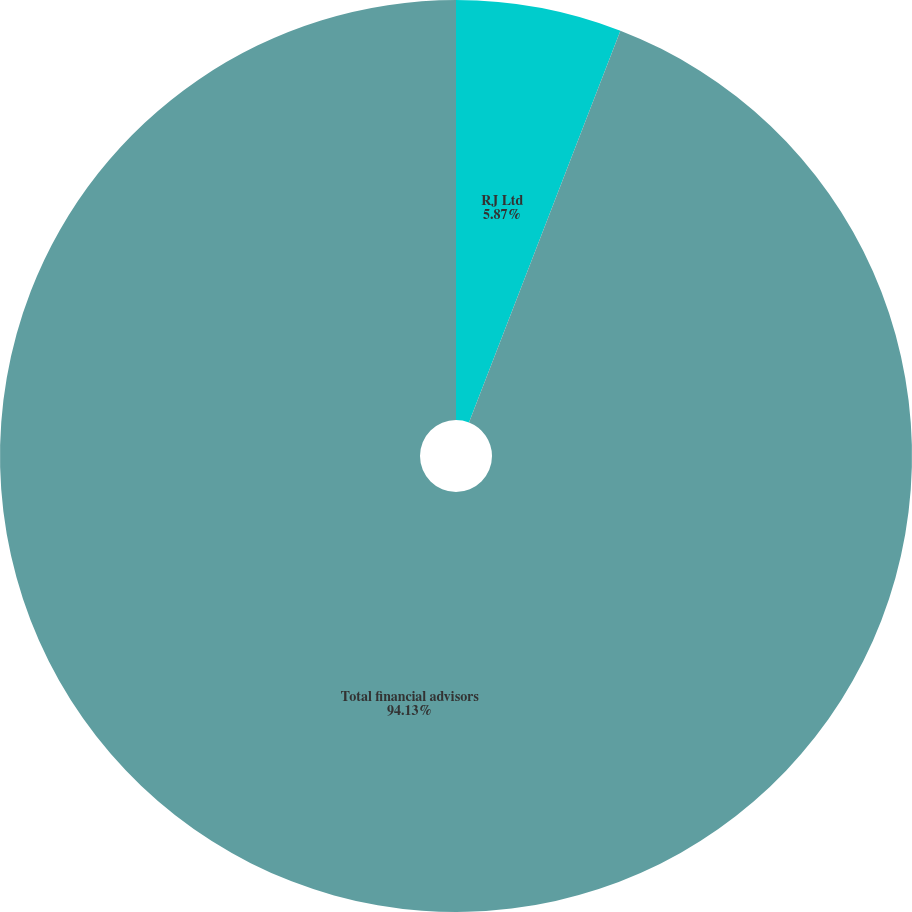<chart> <loc_0><loc_0><loc_500><loc_500><pie_chart><fcel>RJ Ltd<fcel>Total financial advisors<nl><fcel>5.87%<fcel>94.13%<nl></chart> 